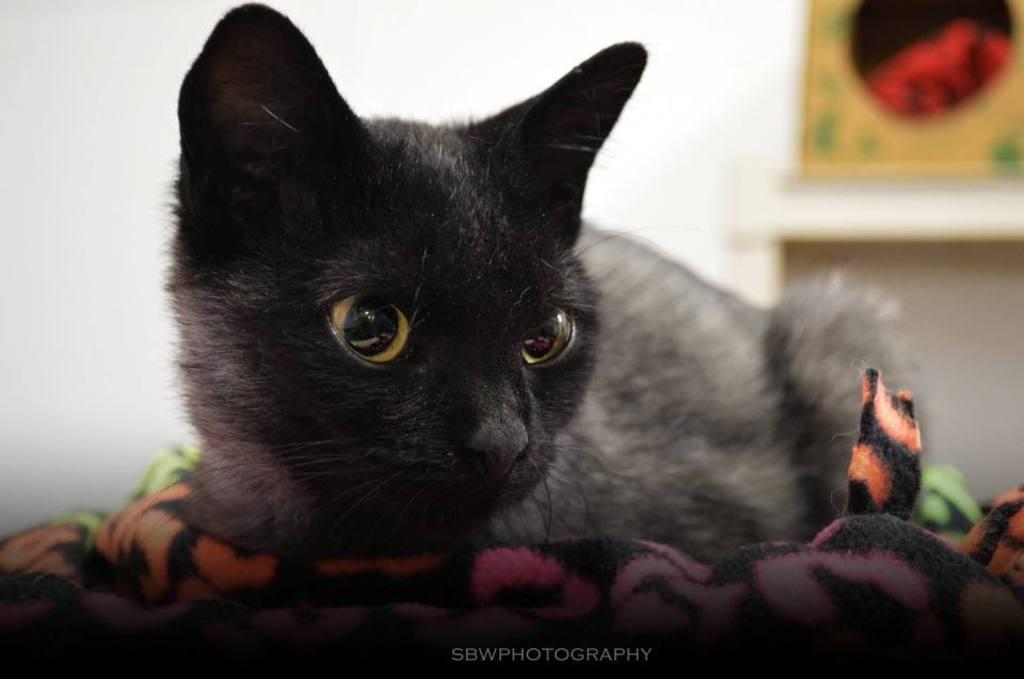What type of animal is in the image? There is a black cat in the image. What is the cat sitting on? The cat is sitting on a cloth. What can be seen in the background of the image? There is a wall in the background of the image. What is attached to the wall? There are two frames attached to the wall. How many birds are in the flock that is flying over the cat in the image? There is no flock of birds present in the image; it only features a black cat sitting on a cloth with a wall and two frames in the background. 